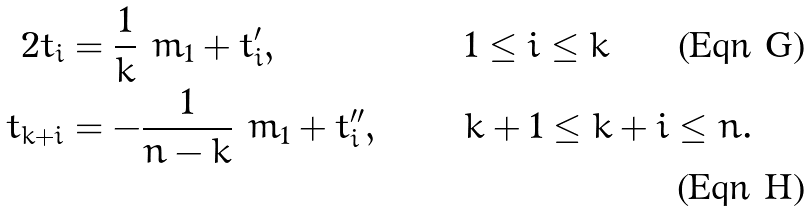<formula> <loc_0><loc_0><loc_500><loc_500>2 t _ { i } & = \frac { 1 } { k } \ m _ { 1 } + t _ { i } ^ { \prime } , \quad & & 1 \leq i \leq k \\ t _ { k + i } & = - \frac { 1 } { n - k } \ m _ { 1 } + t _ { i } ^ { \prime \prime } , \quad & & k + 1 \leq k + i \leq n .</formula> 